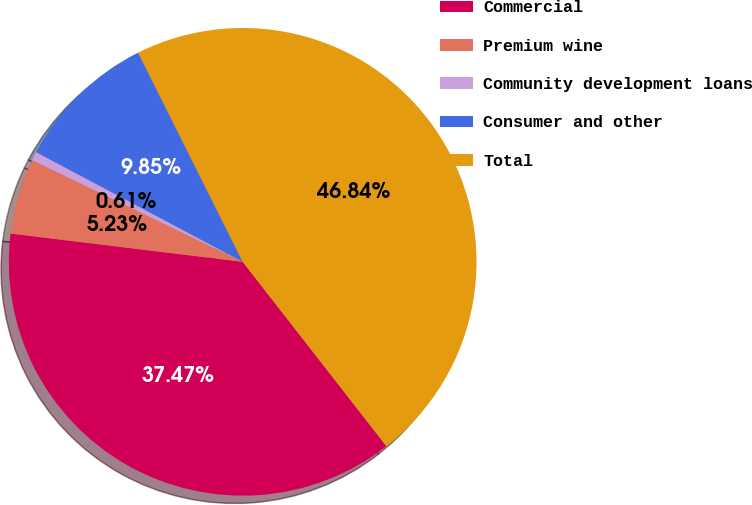Convert chart. <chart><loc_0><loc_0><loc_500><loc_500><pie_chart><fcel>Commercial<fcel>Premium wine<fcel>Community development loans<fcel>Consumer and other<fcel>Total<nl><fcel>37.47%<fcel>5.23%<fcel>0.61%<fcel>9.85%<fcel>46.84%<nl></chart> 